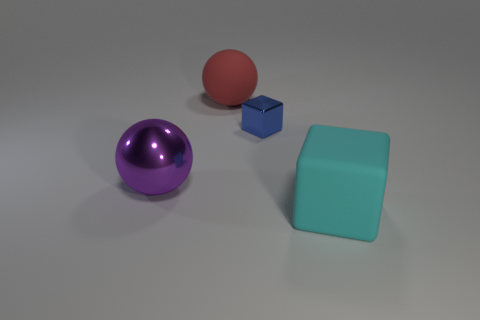How many large metal objects are the same shape as the large red matte object?
Provide a succinct answer. 1. What size is the cyan object that is the same material as the red ball?
Keep it short and to the point. Large. What is the color of the big thing that is to the left of the metal cube and in front of the blue metallic thing?
Provide a short and direct response. Purple. What number of other blocks are the same size as the cyan block?
Your answer should be very brief. 0. What is the size of the thing that is both in front of the metallic block and to the right of the big red thing?
Give a very brief answer. Large. What number of blue metal cubes are on the left side of the cube on the left side of the matte thing in front of the big red matte object?
Offer a very short reply. 0. Are there any big metal things of the same color as the metal sphere?
Keep it short and to the point. No. The matte thing that is the same size as the cyan cube is what color?
Offer a very short reply. Red. What is the shape of the metal object behind the big ball on the left side of the matte thing behind the cyan rubber thing?
Offer a very short reply. Cube. There is a large rubber object that is on the left side of the tiny thing; how many large cyan rubber cubes are in front of it?
Offer a terse response. 1. 